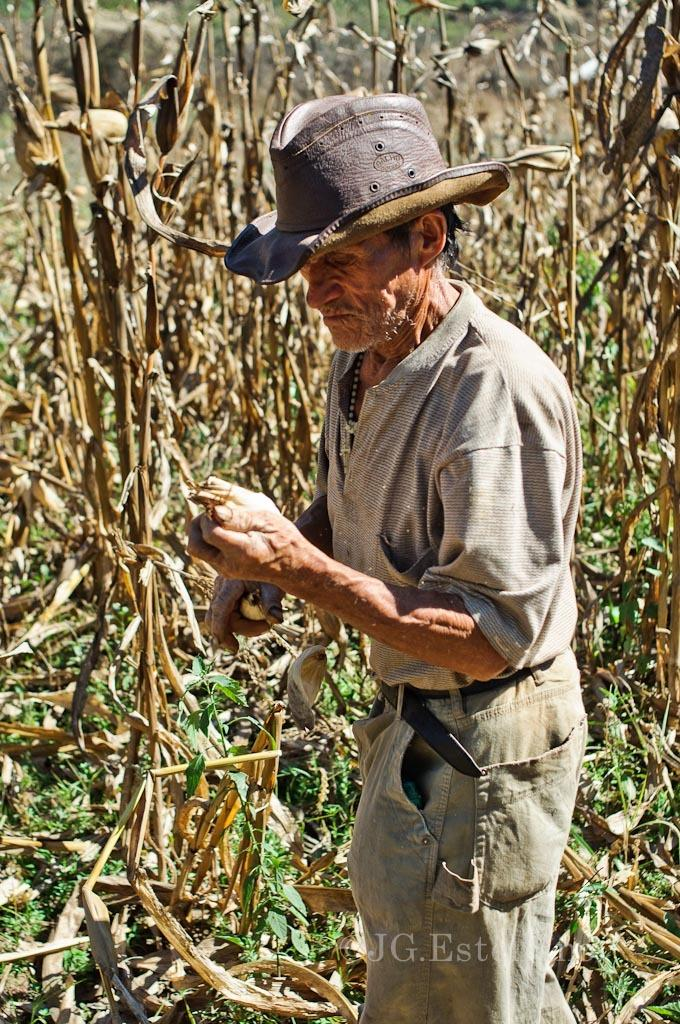What is the main subject of the image? There is a person standing in the image. Can you describe the person's attire? The person is wearing a hat on his head. Are there any other people in the image? Yes, there are other people beside the person in the image. What type of expansion is taking place in the image? There is no expansion taking place in the image; it is a still image of a person and other people. Can you identify any appliances in the image? There is no mention of any appliances in the image, so we cannot identify any. 